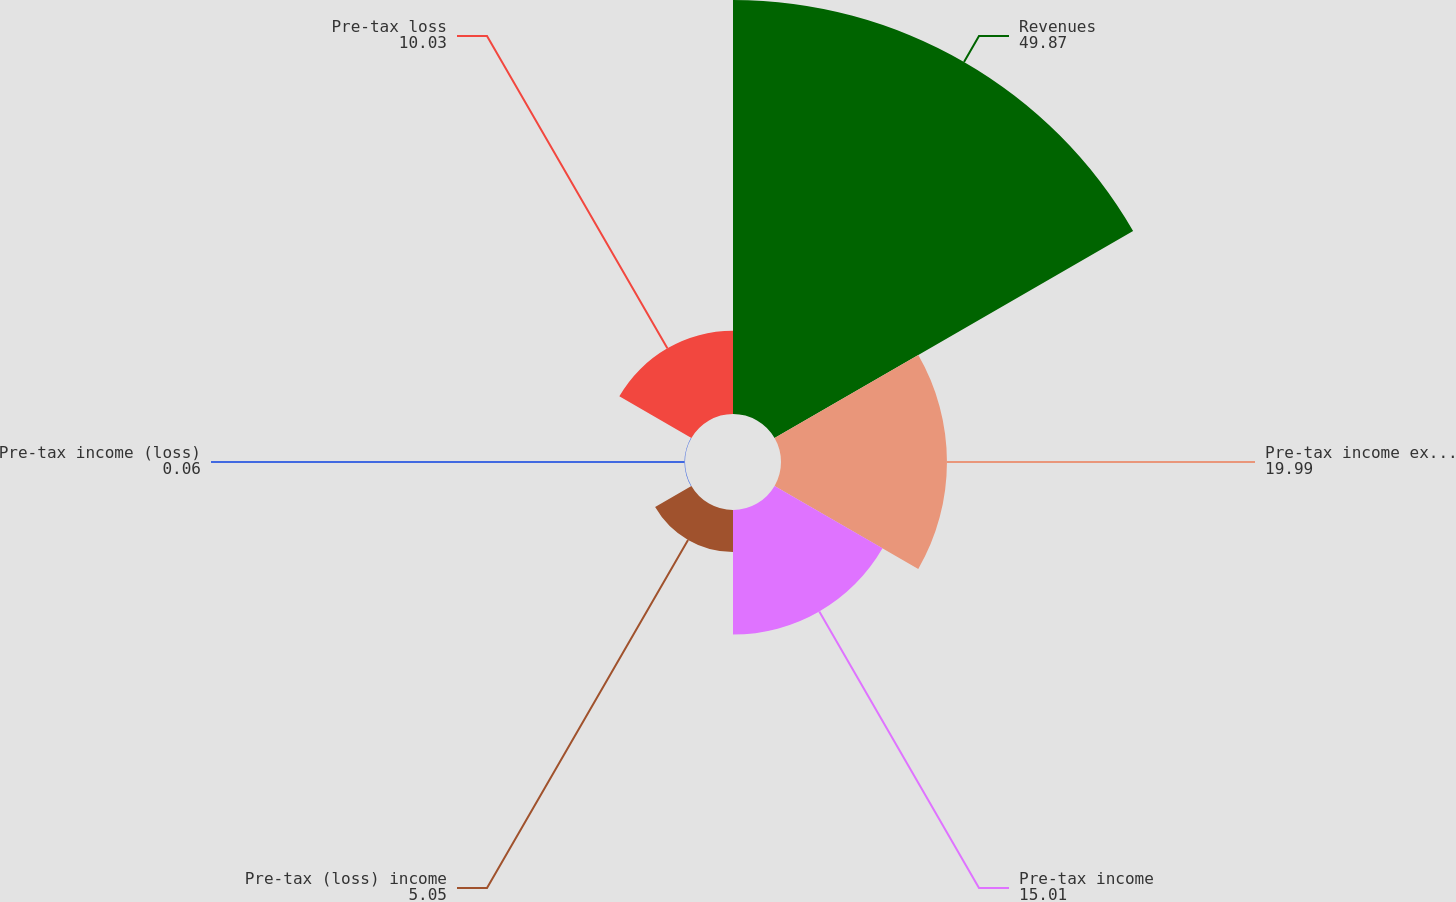Convert chart. <chart><loc_0><loc_0><loc_500><loc_500><pie_chart><fcel>Revenues<fcel>Pre-tax income excluding<fcel>Pre-tax income<fcel>Pre-tax (loss) income<fcel>Pre-tax income (loss)<fcel>Pre-tax loss<nl><fcel>49.87%<fcel>19.99%<fcel>15.01%<fcel>5.05%<fcel>0.06%<fcel>10.03%<nl></chart> 